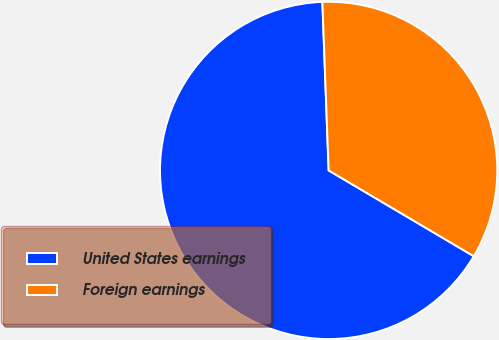Convert chart to OTSL. <chart><loc_0><loc_0><loc_500><loc_500><pie_chart><fcel>United States earnings<fcel>Foreign earnings<nl><fcel>65.91%<fcel>34.09%<nl></chart> 